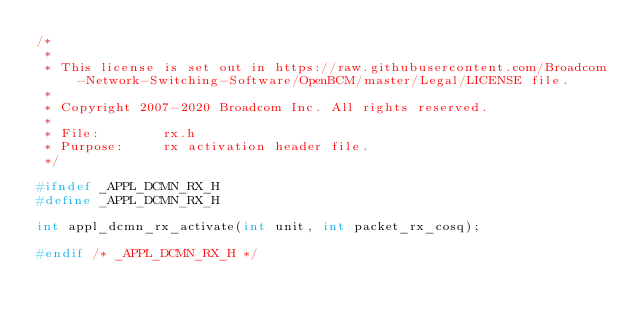Convert code to text. <code><loc_0><loc_0><loc_500><loc_500><_C_>/* 
 * 
 * This license is set out in https://raw.githubusercontent.com/Broadcom-Network-Switching-Software/OpenBCM/master/Legal/LICENSE file.
 * 
 * Copyright 2007-2020 Broadcom Inc. All rights reserved.
 *
 * File:        rx.h
 * Purpose:     rx activation header file.
 */

#ifndef _APPL_DCMN_RX_H
#define _APPL_DCMN_RX_H

int appl_dcmn_rx_activate(int unit, int packet_rx_cosq);

#endif /* _APPL_DCMN_RX_H */
</code> 